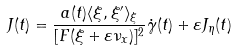Convert formula to latex. <formula><loc_0><loc_0><loc_500><loc_500>J ( t ) = \frac { a ( t ) \langle \xi , \xi ^ { \prime } \rangle _ { \xi } } { [ F ( \xi + \varepsilon \nu _ { x } ) ] ^ { 2 } } \dot { \gamma } ( t ) + \varepsilon J _ { \eta } ( t )</formula> 